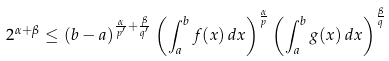Convert formula to latex. <formula><loc_0><loc_0><loc_500><loc_500>2 ^ { \alpha + \beta } \leq ( b - a ) ^ { \frac { \alpha } { p ^ { \prime } } + \frac { \beta } { q ^ { \prime } } } \left ( \int _ { a } ^ { b } f ( x ) \, d x \right ) ^ { \frac { \alpha } { p } } \left ( \int _ { a } ^ { b } g ( x ) \, d x \right ) ^ { \frac { \beta } { q } }</formula> 